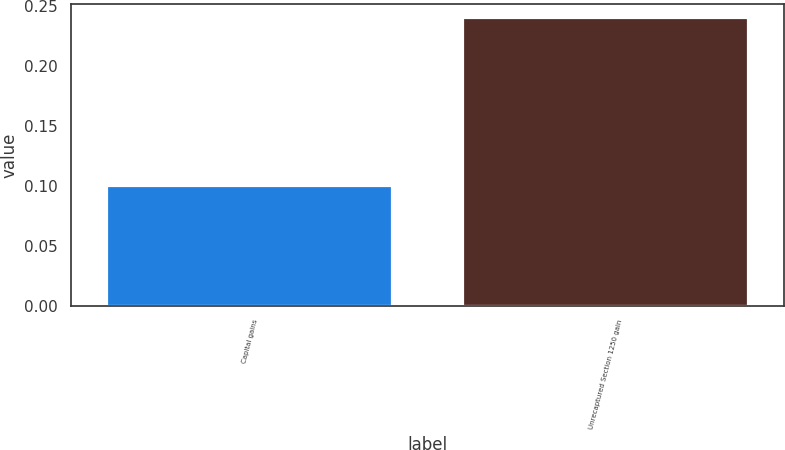Convert chart to OTSL. <chart><loc_0><loc_0><loc_500><loc_500><bar_chart><fcel>Capital gains<fcel>Unrecaptured Section 1250 gain<nl><fcel>0.1<fcel>0.24<nl></chart> 